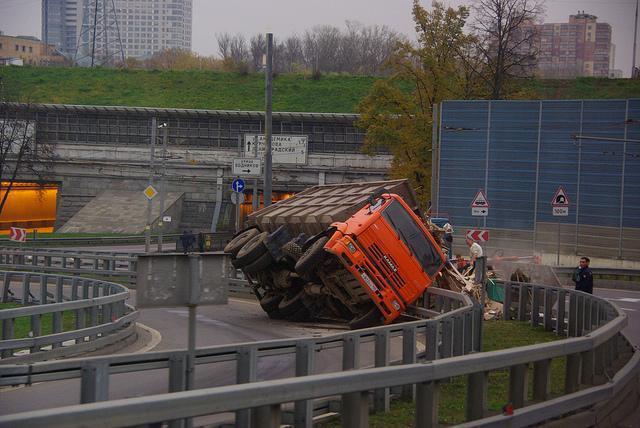Which speed during the turn caused this to happen?
From the following set of four choices, select the accurate answer to respond to the question.
Options: Stopping, decelerating, high, low. High. 